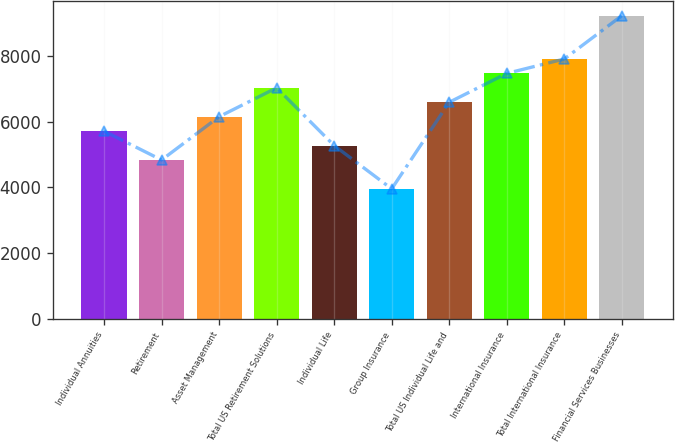<chart> <loc_0><loc_0><loc_500><loc_500><bar_chart><fcel>Individual Annuities<fcel>Retirement<fcel>Asset Management<fcel>Total US Retirement Solutions<fcel>Individual Life<fcel>Group Insurance<fcel>Total US Individual Life and<fcel>International Insurance<fcel>Total International Insurance<fcel>Financial Services Businesses<nl><fcel>5708.62<fcel>4831.52<fcel>6147.17<fcel>7024.27<fcel>5270.07<fcel>3954.42<fcel>6585.72<fcel>7462.82<fcel>7901.37<fcel>9217.02<nl></chart> 